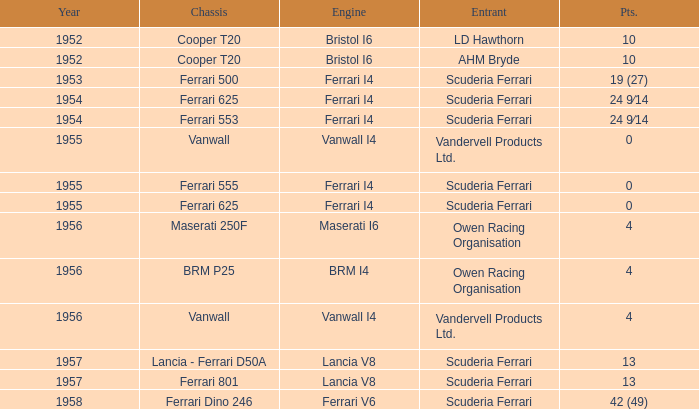Who is the entrant when the year is less than 1953? LD Hawthorn, AHM Bryde. 